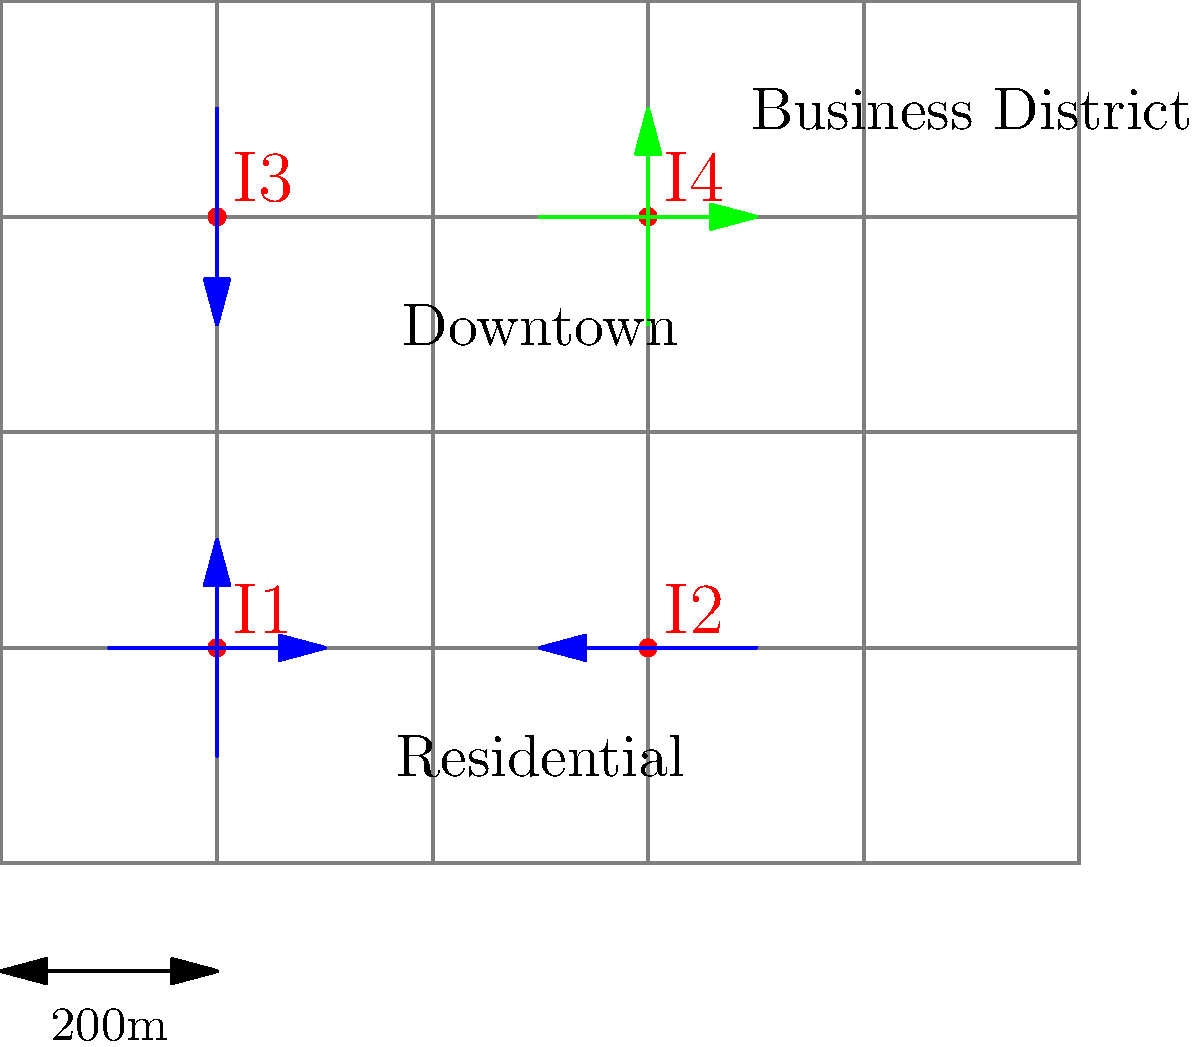As a senior journalism professor with experience in political reporting, you've been asked to analyze a city's traffic management strategy. The map shows the main intersections (I1, I2, I3, I4) and traffic flow patterns in a city's core area. Blue arrows indicate heavy morning traffic, while green arrows show evening traffic patterns. Based on this information, which intersection is likely to be the most critical for the city's traffic management system, and why might this be significant from a political perspective? To answer this question, we need to analyze the traffic flow patterns and their implications:

1. Observe the traffic flow:
   - Blue arrows (morning traffic) converge towards I2 (60,20)
   - Green arrows (evening traffic) originate from I4 (60,60)

2. Identify the critical intersection:
   - I2 appears to be the most critical as it receives traffic from multiple directions in the morning
   - This suggests I2 is likely near the business district or downtown area

3. Analyze the political significance:
   a) Traffic management is a key urban issue that affects citizens' daily lives
   b) Efficient traffic flow at I2 could impact:
      - Commute times
      - Air quality (due to idling vehicles)
      - Economic productivity
      - Overall quality of life

4. Political implications:
   a) Success or failure in managing this intersection could influence:
      - Public opinion of local government
      - Election outcomes for city officials
      - Allocation of city resources
   b) It may become a focal point for:
      - Infrastructure investment decisions
      - Urban planning policies
      - Environmental initiatives

5. Journalistic angle:
   - This intersection could be a key location for reporting on urban issues
   - It provides a concrete example of how policy decisions affect daily life
   - Stories about traffic at I2 could illustrate broader themes of urban governance

By identifying I2 as the critical intersection and understanding its political significance, a journalist can effectively report on the intersection of urban planning, local politics, and quality of life issues.
Answer: Intersection I2, due to its central role in morning traffic flow and potential impact on commute times, air quality, and economic productivity, making it a politically significant focal point for urban management and policy decisions. 